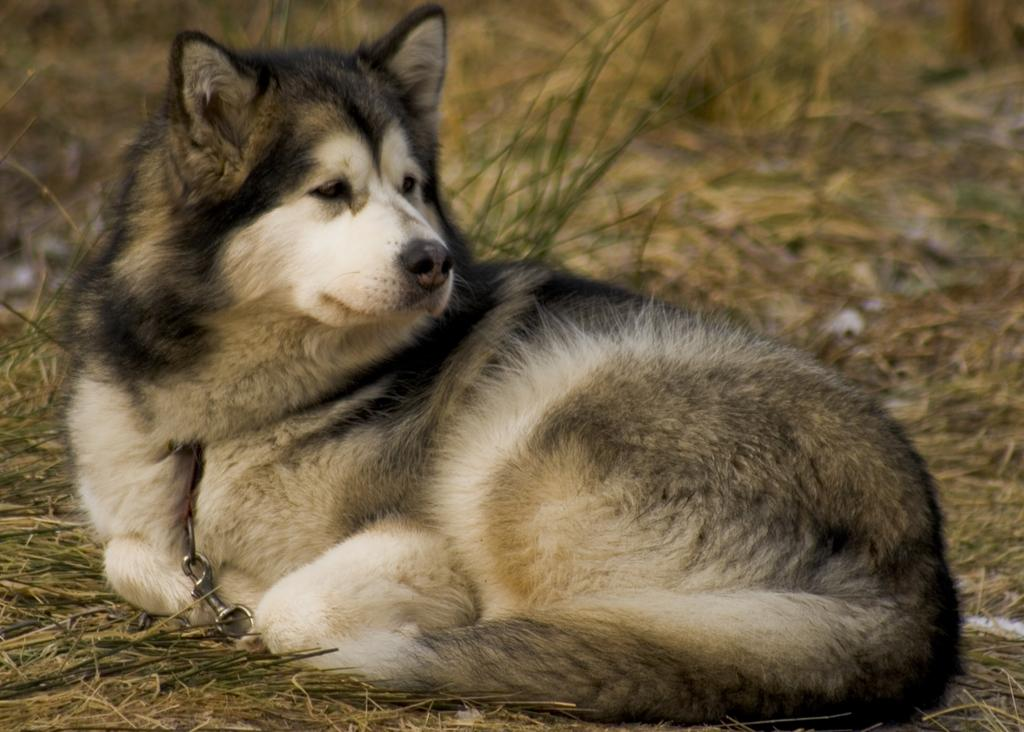What type of creature is in the image? There is an animal in the image. Where is the animal located? The animal is on a grass surface. What can be observed about the background in the image? The background of the animal is blurred. What message does the animal convey to the viewer as it says good-bye in the image? There is no indication in the image that the animal is saying good-bye or conveying any message. 